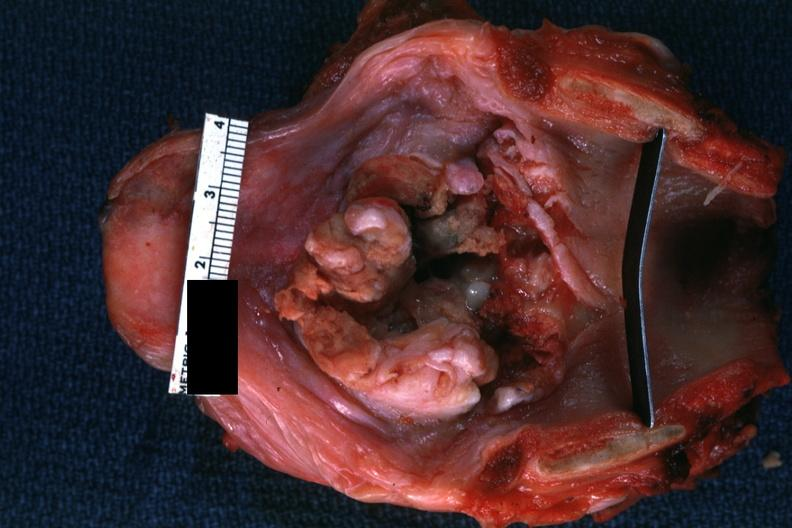what is present?
Answer the question using a single word or phrase. Larynx 